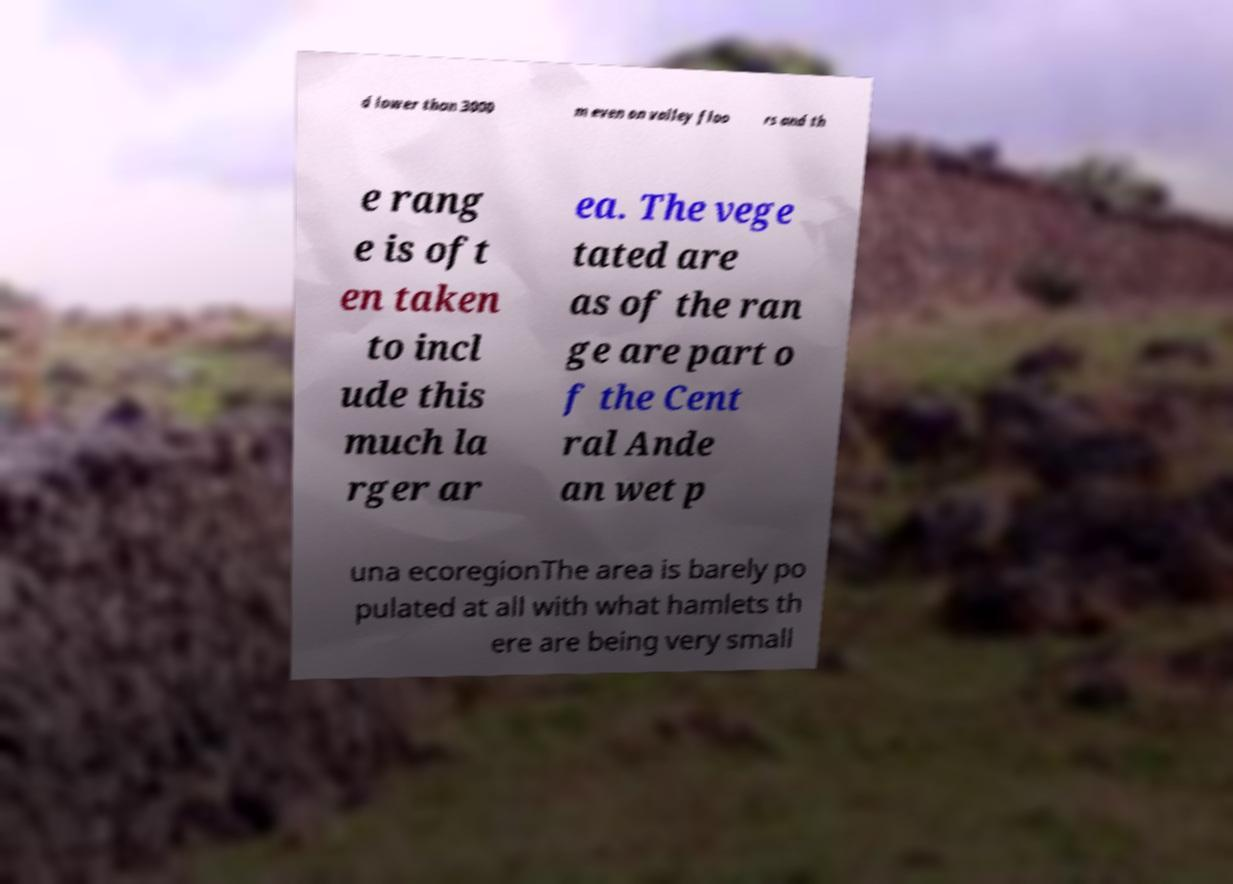There's text embedded in this image that I need extracted. Can you transcribe it verbatim? d lower than 3000 m even on valley floo rs and th e rang e is oft en taken to incl ude this much la rger ar ea. The vege tated are as of the ran ge are part o f the Cent ral Ande an wet p una ecoregionThe area is barely po pulated at all with what hamlets th ere are being very small 